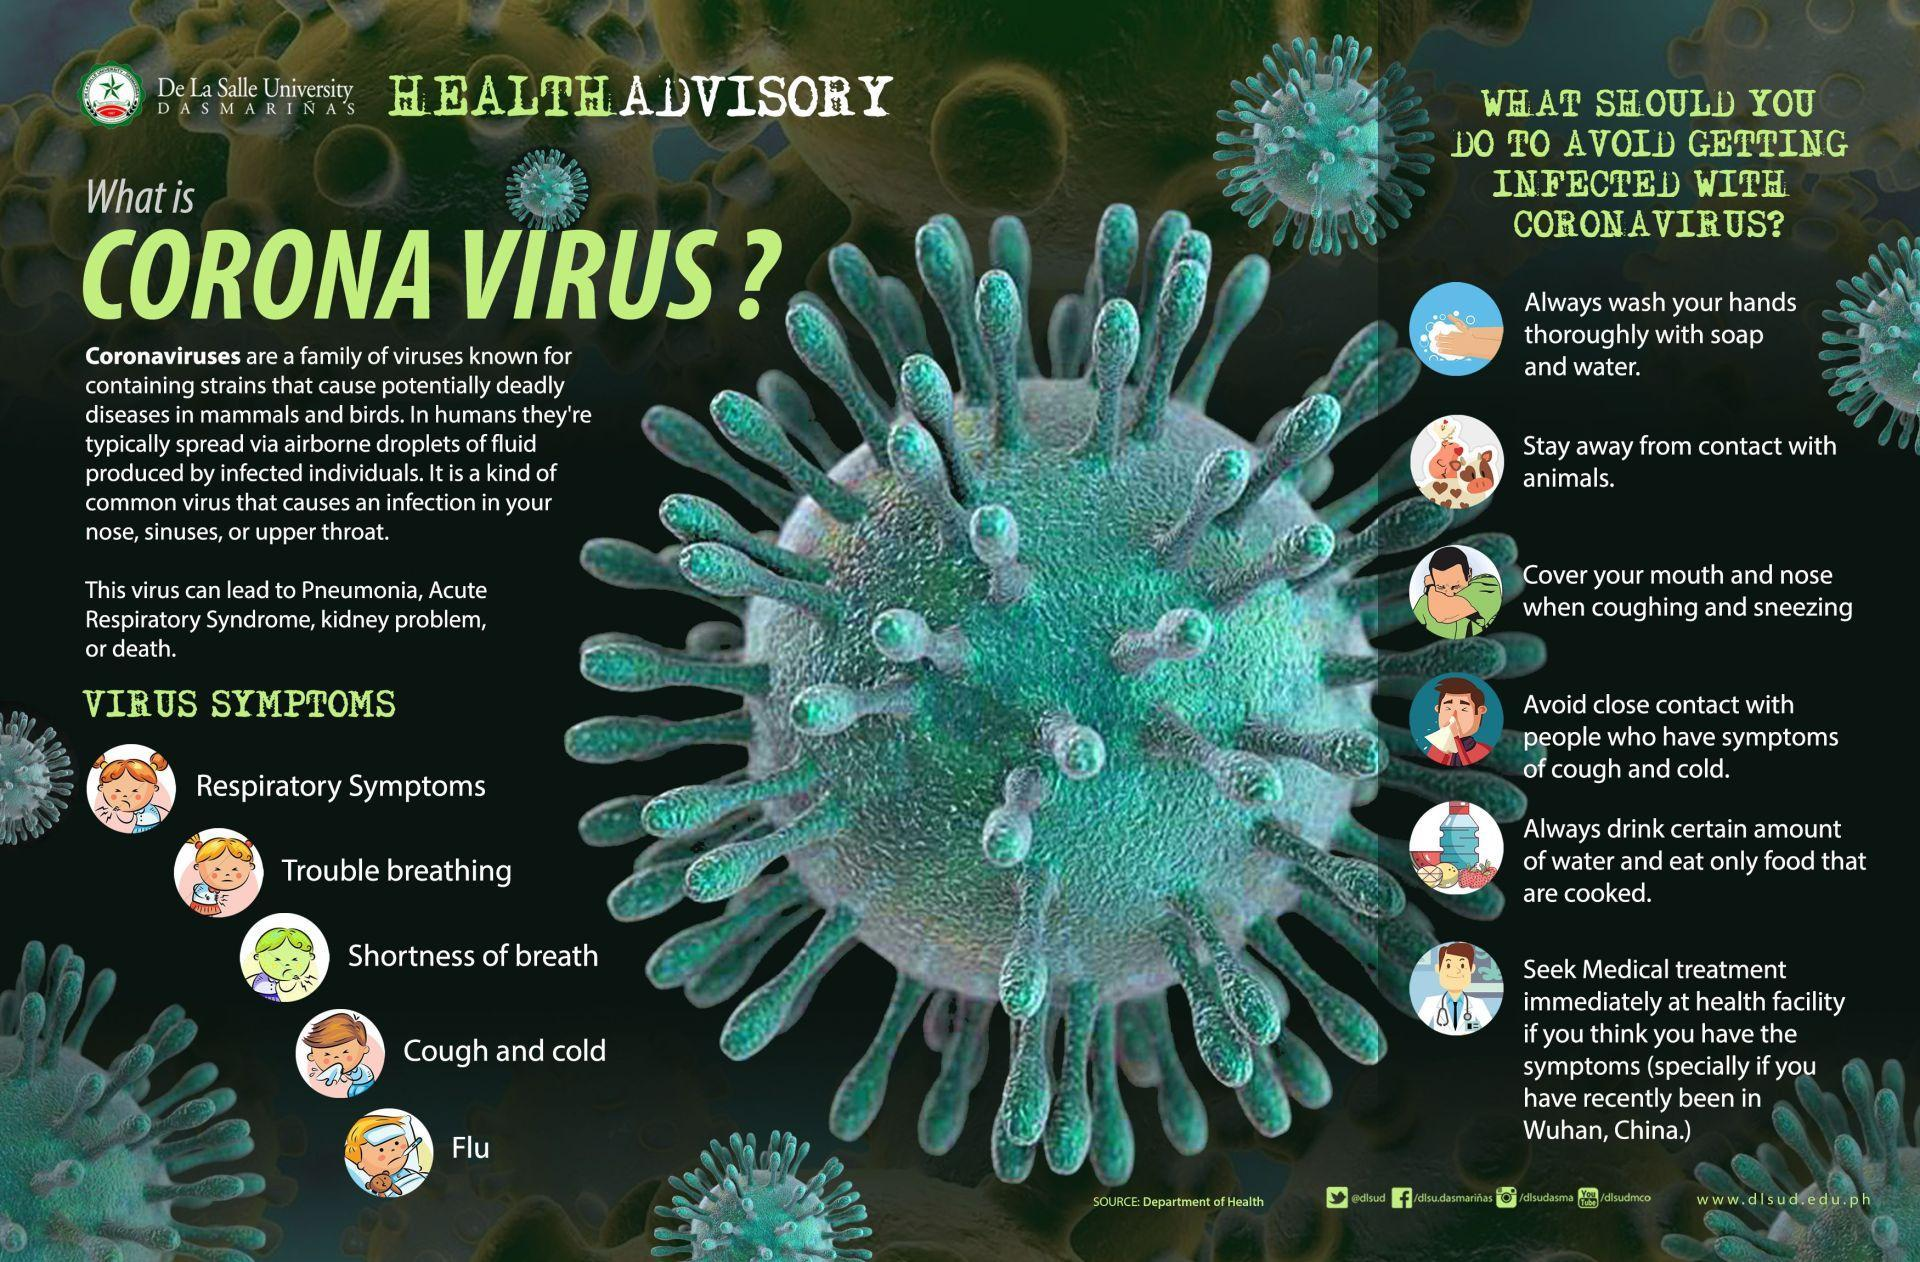Which is the second symptom in this infographic?
Answer the question with a short phrase. Trouble breathing Which is the third symptom in this infographic? Shortness of breath How many symptoms are in this infographic? 5 How many points are under the heading "What should you do to avoid getting infected with coronavirus"? 6 Which is the fifth symptom in this infographic? Flu 